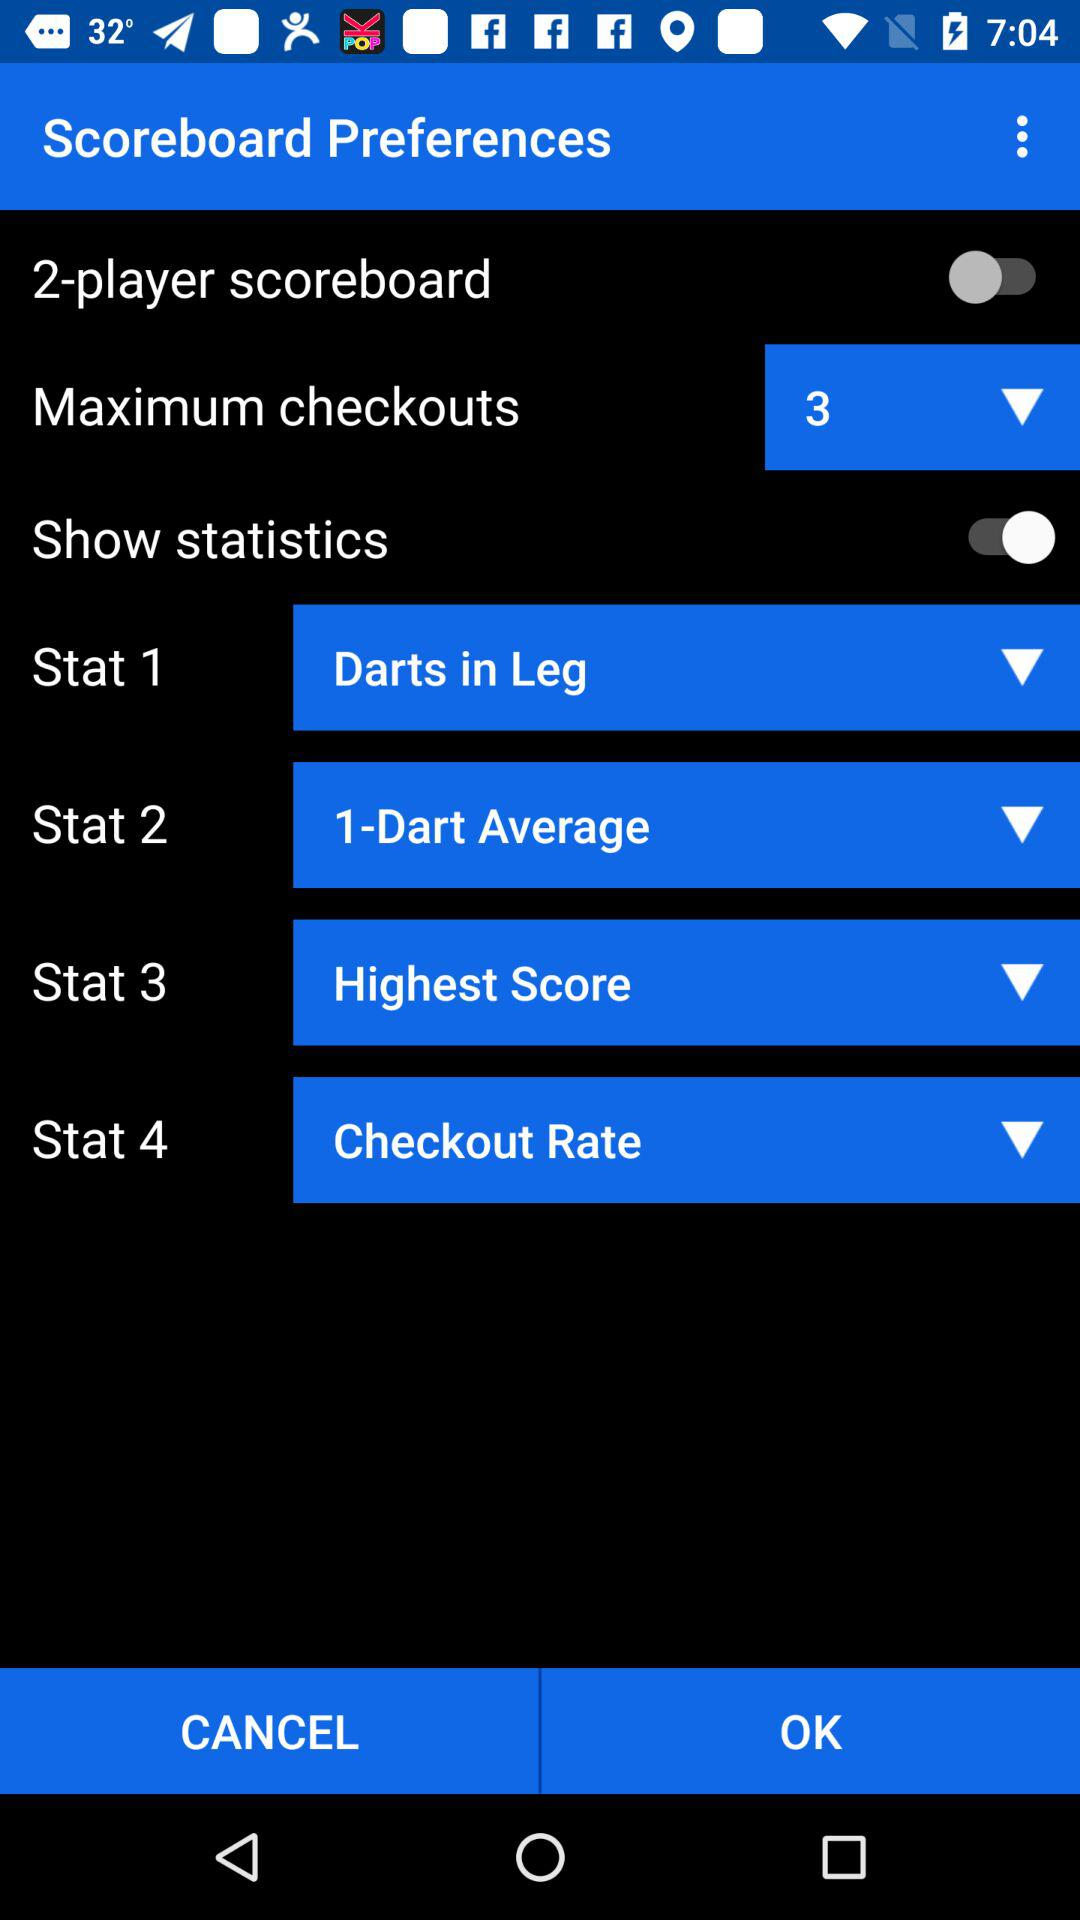What does "Stat 4" show? The "Stat 4" shows the checkout rate. 